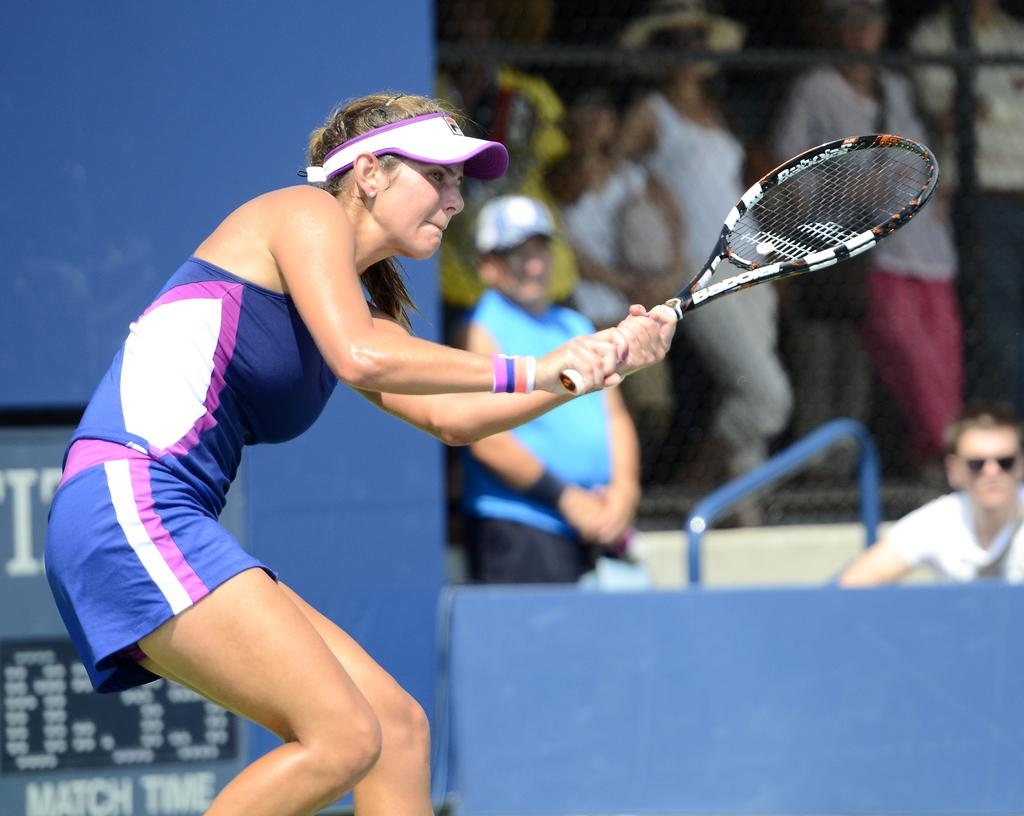Who can be seen in the image? There are people in the image. What is the banner in the image used for? The purpose of the banner in the image is not specified, but it is present. Can you describe the woman standing in the front of the image? The woman standing in the front of the image is wearing a blue dress and holding a tennis racket. What type of lace is used in the woman's dress in the image? The woman's dress in the image is described as blue, but there is no mention of lace being used in its design. 